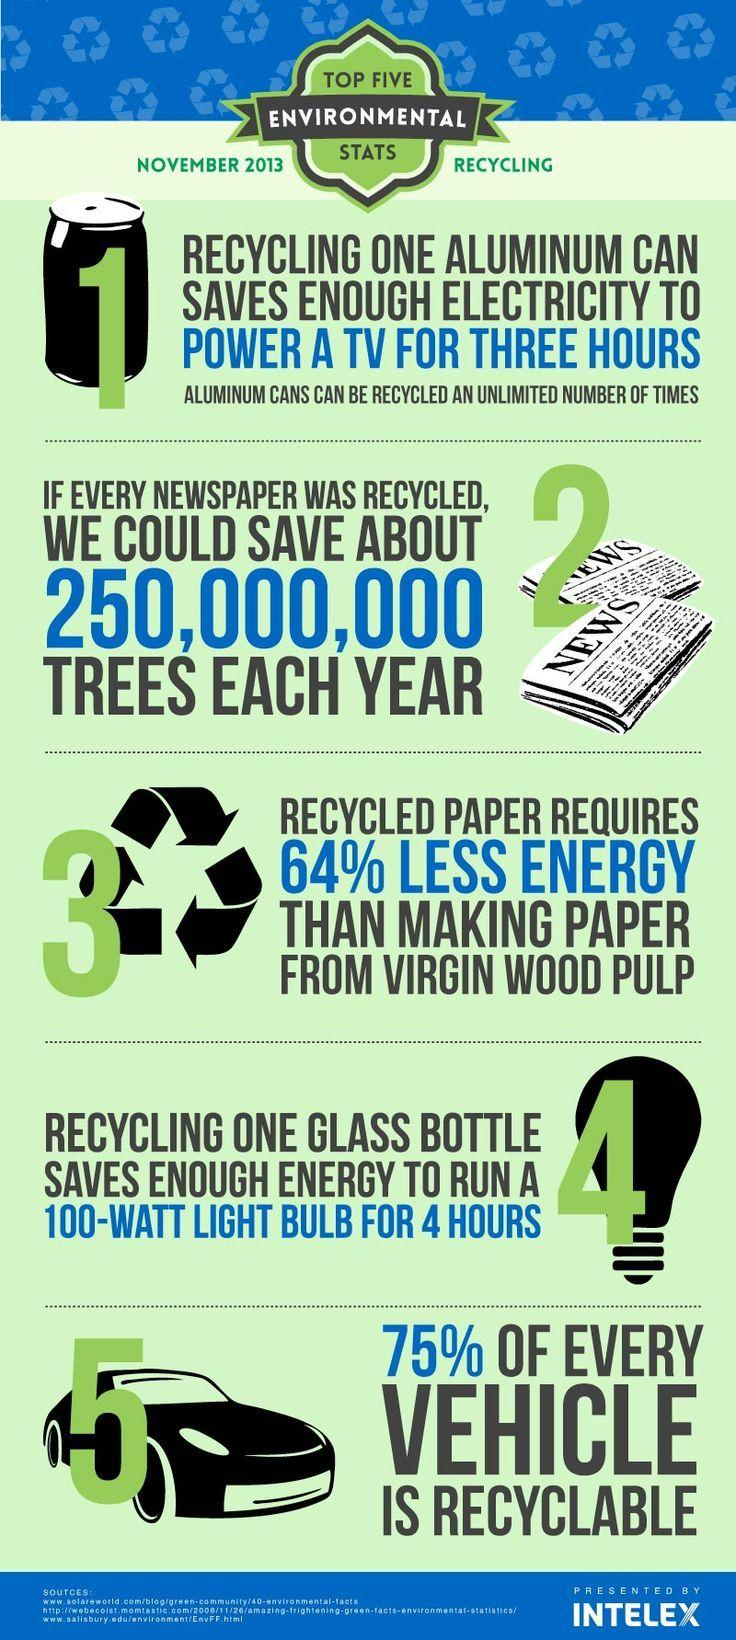List a handful of essential elements in this visual. Producing paper from virgin wood pulp requires significantly more energy than producing paper from recycled paper. 